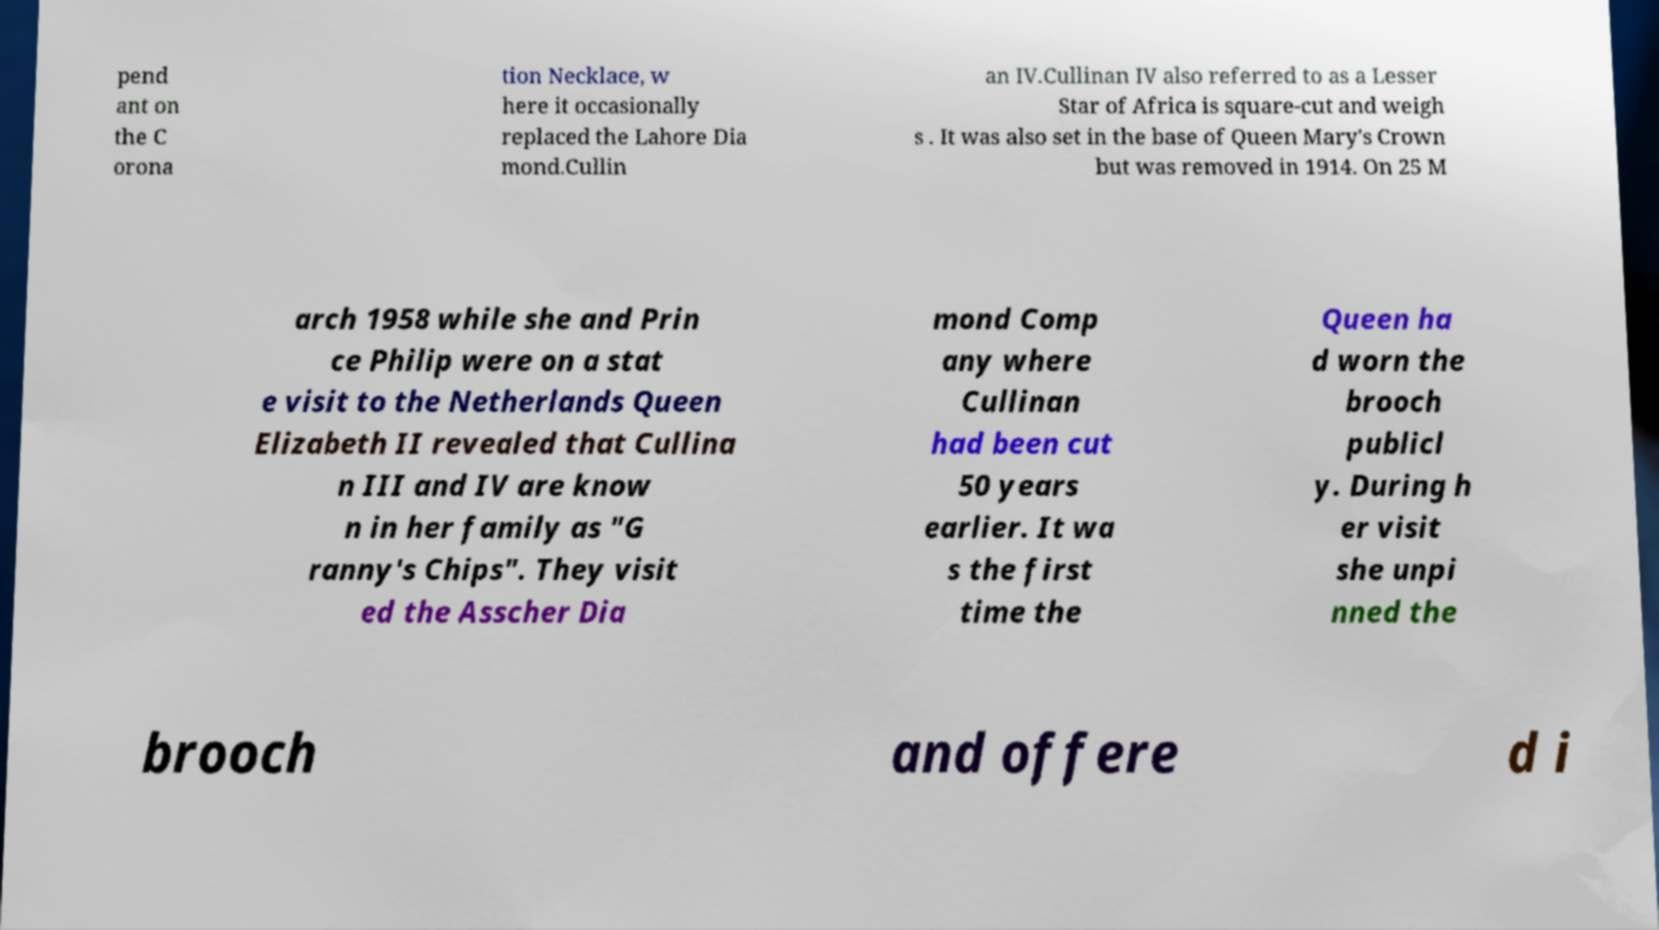Can you accurately transcribe the text from the provided image for me? pend ant on the C orona tion Necklace, w here it occasionally replaced the Lahore Dia mond.Cullin an IV.Cullinan IV also referred to as a Lesser Star of Africa is square-cut and weigh s . It was also set in the base of Queen Mary's Crown but was removed in 1914. On 25 M arch 1958 while she and Prin ce Philip were on a stat e visit to the Netherlands Queen Elizabeth II revealed that Cullina n III and IV are know n in her family as "G ranny's Chips". They visit ed the Asscher Dia mond Comp any where Cullinan had been cut 50 years earlier. It wa s the first time the Queen ha d worn the brooch publicl y. During h er visit she unpi nned the brooch and offere d i 